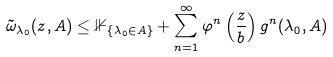Convert formula to latex. <formula><loc_0><loc_0><loc_500><loc_500>\tilde { \omega } _ { \lambda _ { 0 } } ( z , A ) \leq \mathbb { 1 } _ { \{ \lambda _ { 0 } \in A \} } + \sum _ { n = 1 } ^ { \infty } \varphi ^ { n } \left ( \frac { z } { b } \right ) g ^ { n } ( \lambda _ { 0 } , A )</formula> 